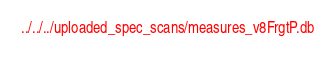Convert code to text. <code><loc_0><loc_0><loc_500><loc_500><_SML_>../../../uploaded_spec_scans/measures_v8FrgtP.db
</code> 